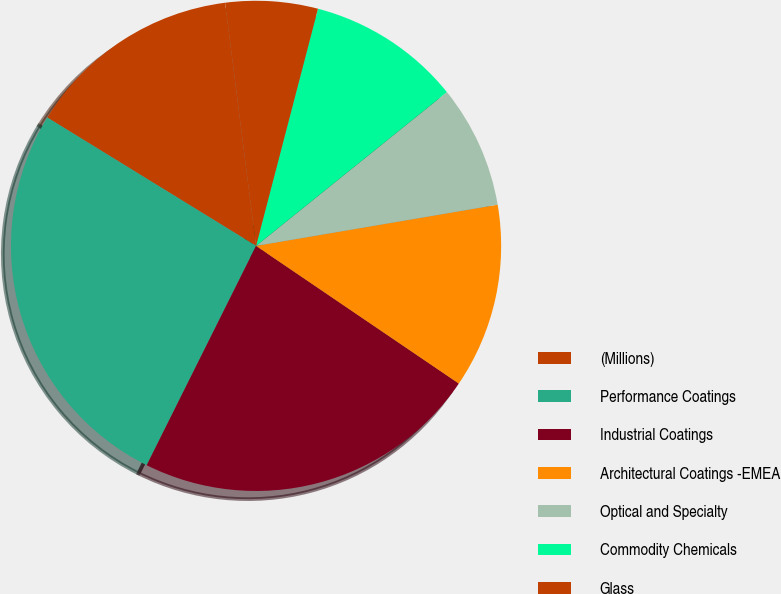Convert chart to OTSL. <chart><loc_0><loc_0><loc_500><loc_500><pie_chart><fcel>(Millions)<fcel>Performance Coatings<fcel>Industrial Coatings<fcel>Architectural Coatings -EMEA<fcel>Optical and Specialty<fcel>Commodity Chemicals<fcel>Glass<nl><fcel>14.21%<fcel>26.41%<fcel>22.87%<fcel>12.18%<fcel>8.11%<fcel>10.14%<fcel>6.08%<nl></chart> 